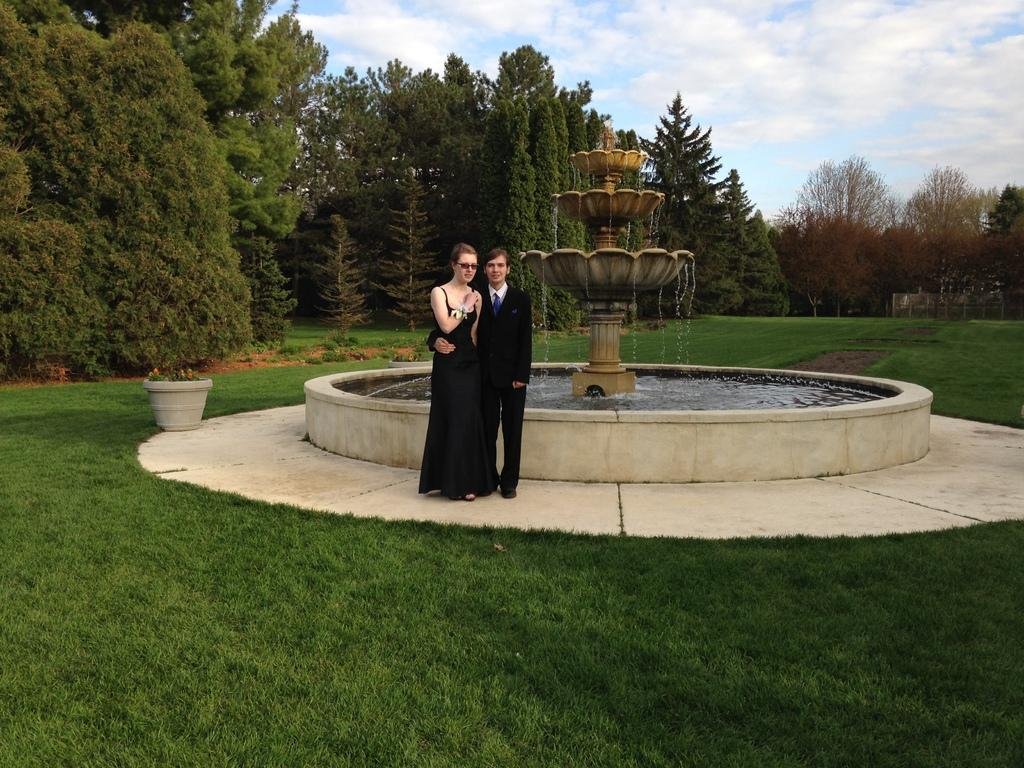How many people are present in the image? There is a man and a woman present in the image. What are the man and woman doing in the image? The man and woman are standing near a fountain. What can be seen in the background of the image? There is sky, clouds, trees, ground, a house plant, and a fountain visible in the background of the image. What type of competition is taking place near the arch in the image? There is no arch present in the image, and therefore no competition can be observed. 